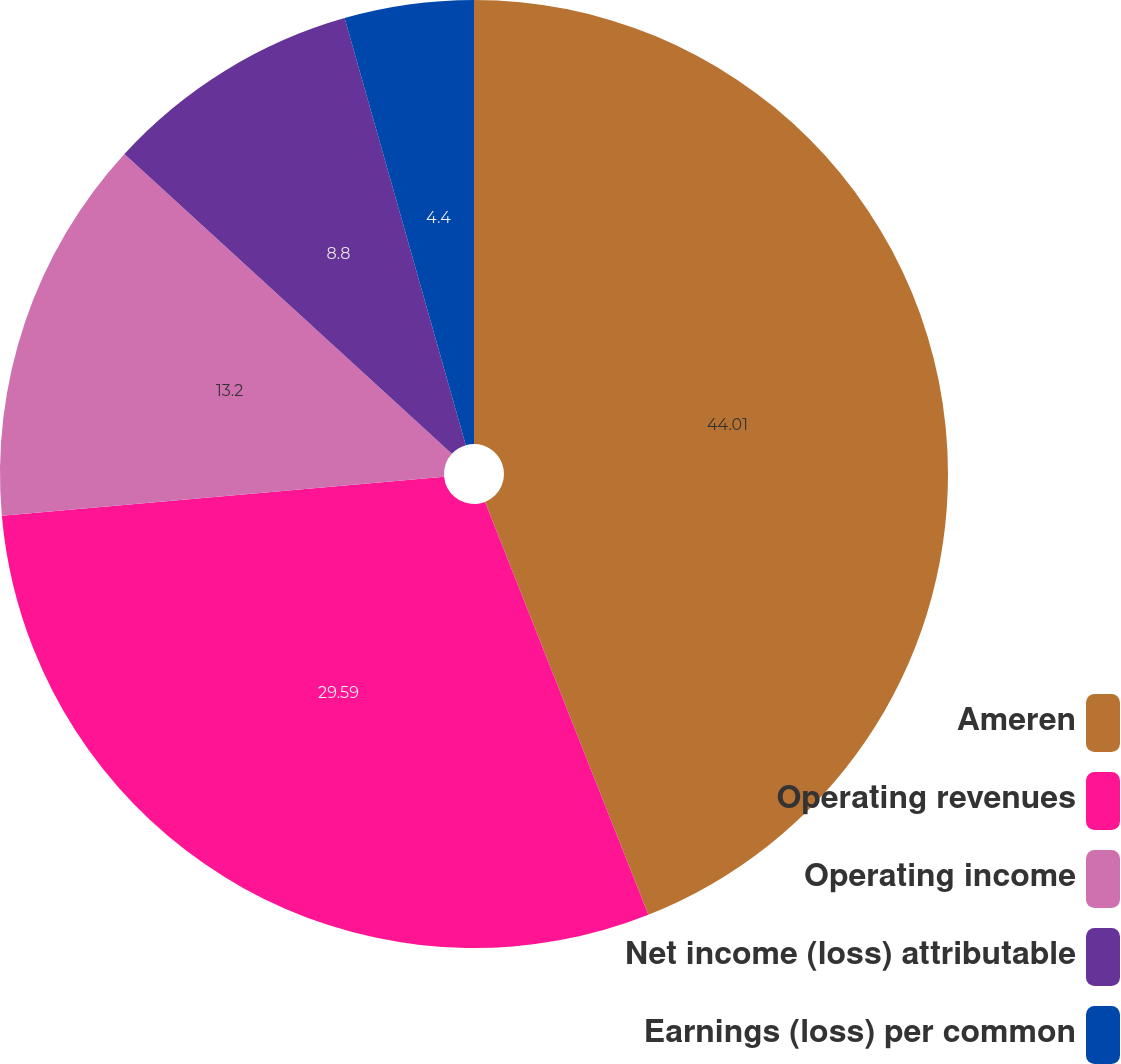Convert chart to OTSL. <chart><loc_0><loc_0><loc_500><loc_500><pie_chart><fcel>Ameren<fcel>Operating revenues<fcel>Operating income<fcel>Net income (loss) attributable<fcel>Earnings (loss) per common<nl><fcel>44.0%<fcel>29.59%<fcel>13.2%<fcel>8.8%<fcel>4.4%<nl></chart> 